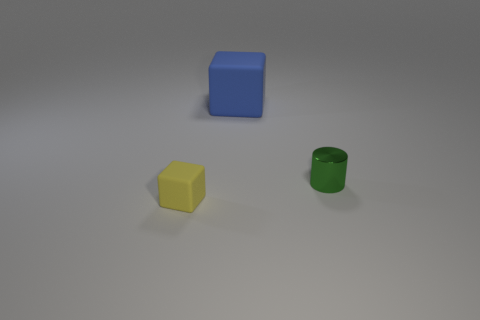Are there any other rubber things of the same shape as the large blue rubber object?
Ensure brevity in your answer.  Yes. The thing that is both left of the green thing and behind the tiny rubber block has what shape?
Your response must be concise. Cube. What number of big blue blocks are the same material as the yellow block?
Offer a very short reply. 1. Are there fewer yellow things that are right of the small green metal thing than blocks?
Provide a short and direct response. Yes. There is a matte object behind the tiny rubber cube; is there a matte block right of it?
Your response must be concise. No. Is there anything else that is the same shape as the small green metal object?
Your answer should be very brief. No. Is the size of the shiny object the same as the blue cube?
Keep it short and to the point. No. What is the material of the small thing right of the tiny thing that is on the left side of the matte block that is behind the green thing?
Make the answer very short. Metal. Are there an equal number of tiny matte things behind the tiny yellow matte object and gray matte spheres?
Offer a terse response. Yes. Is there anything else that is the same size as the blue cube?
Give a very brief answer. No. 